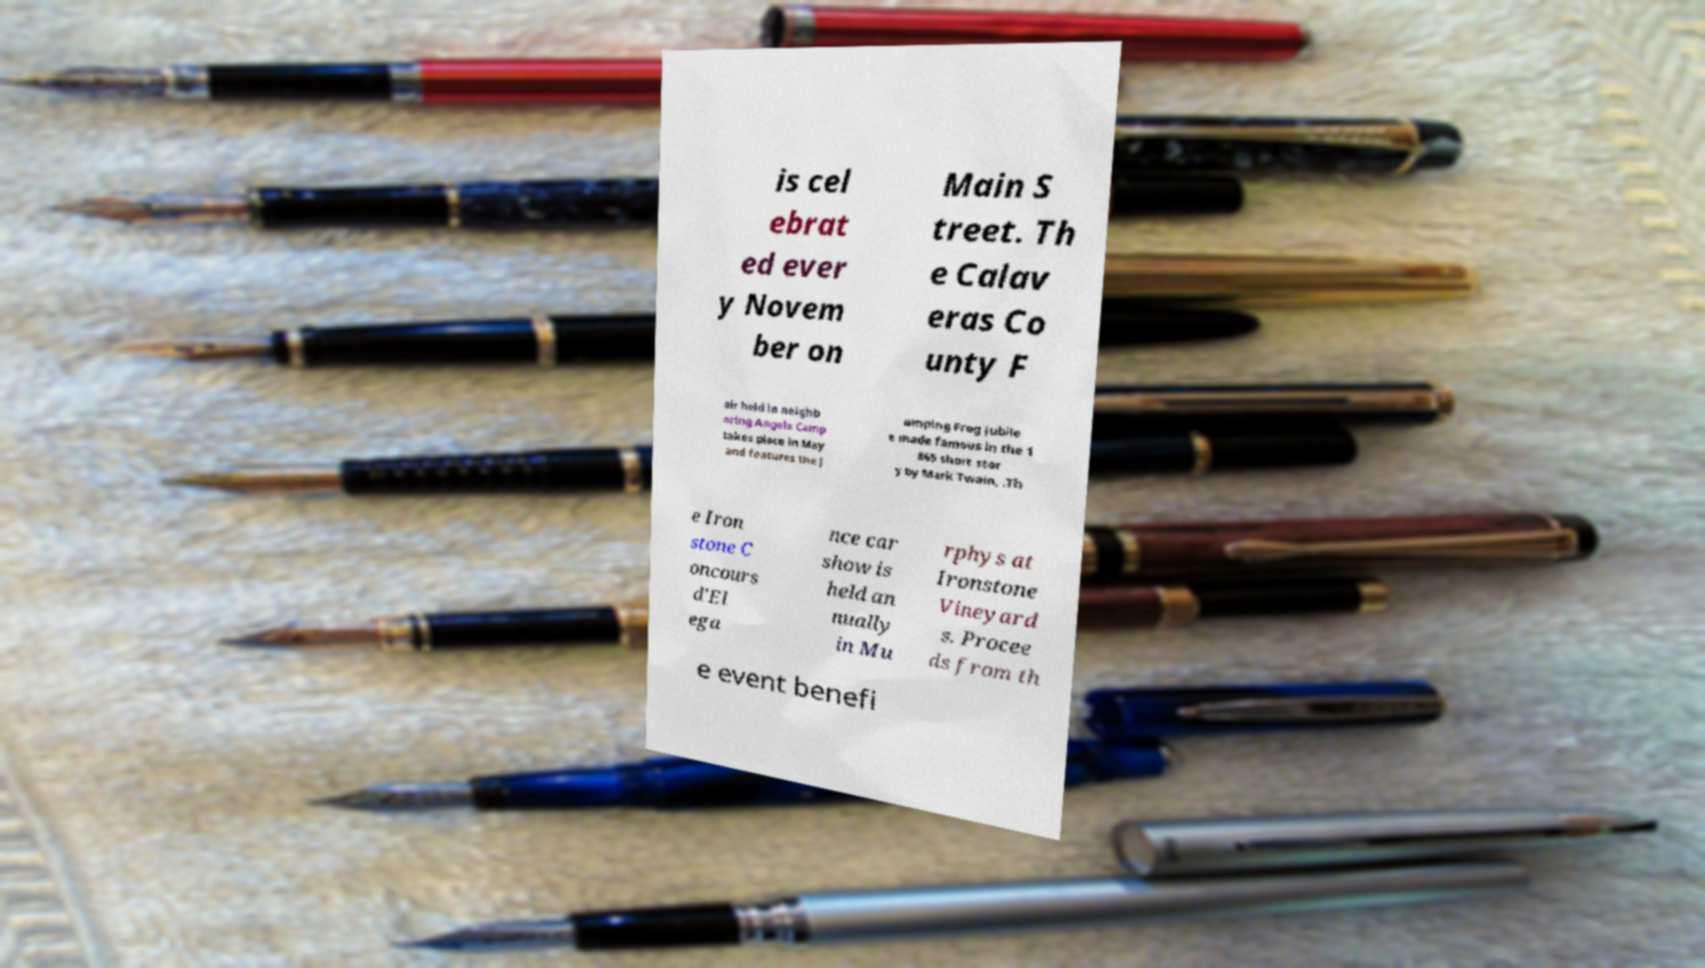I need the written content from this picture converted into text. Can you do that? is cel ebrat ed ever y Novem ber on Main S treet. Th e Calav eras Co unty F air held in neighb oring Angels Camp takes place in May and features the J umping Frog Jubile e made famous in the 1 865 short stor y by Mark Twain, .Th e Iron stone C oncours d'El ega nce car show is held an nually in Mu rphys at Ironstone Vineyard s. Procee ds from th e event benefi 